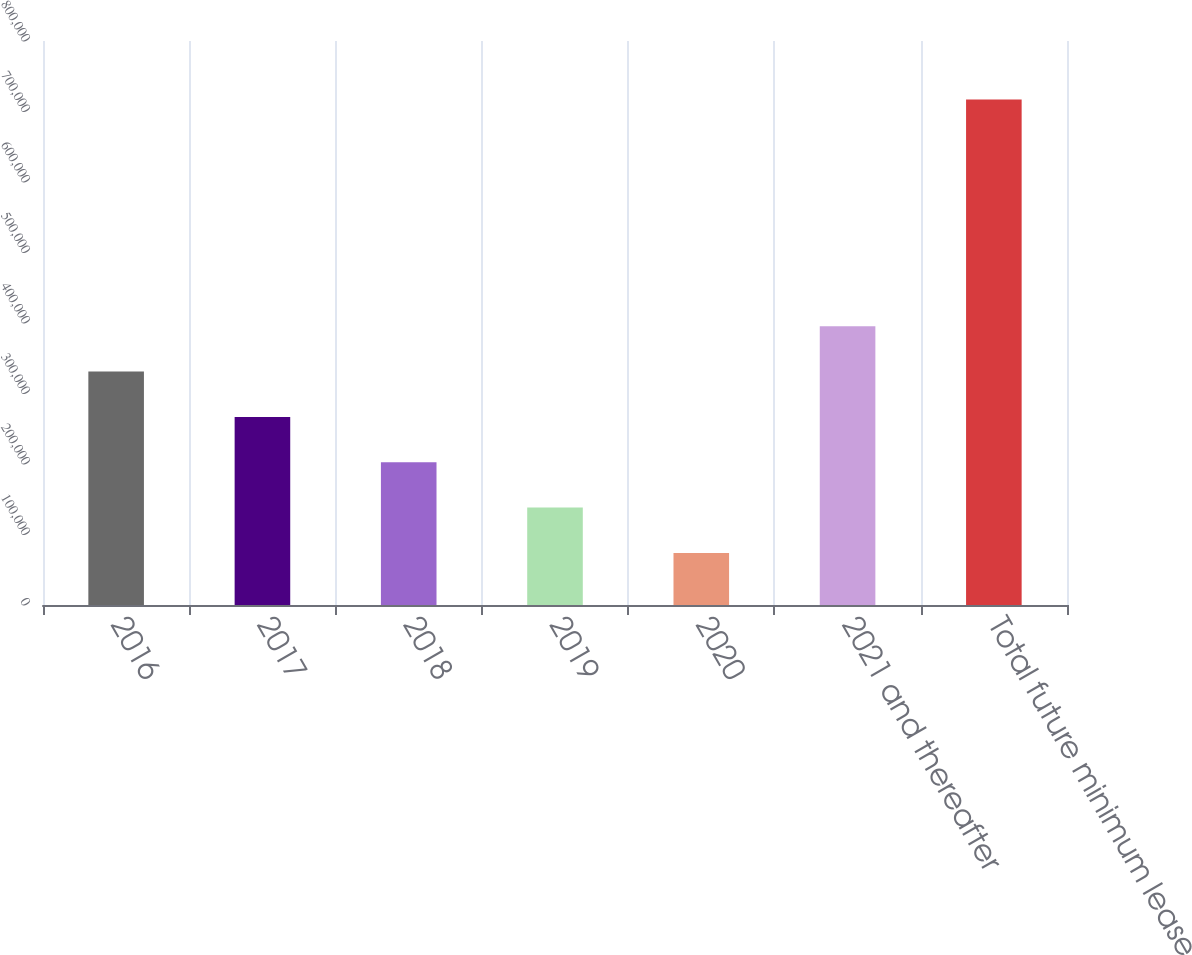Convert chart to OTSL. <chart><loc_0><loc_0><loc_500><loc_500><bar_chart><fcel>2016<fcel>2017<fcel>2018<fcel>2019<fcel>2020<fcel>2021 and thereafter<fcel>Total future minimum lease<nl><fcel>331114<fcel>266788<fcel>202461<fcel>138135<fcel>73808<fcel>395441<fcel>717074<nl></chart> 